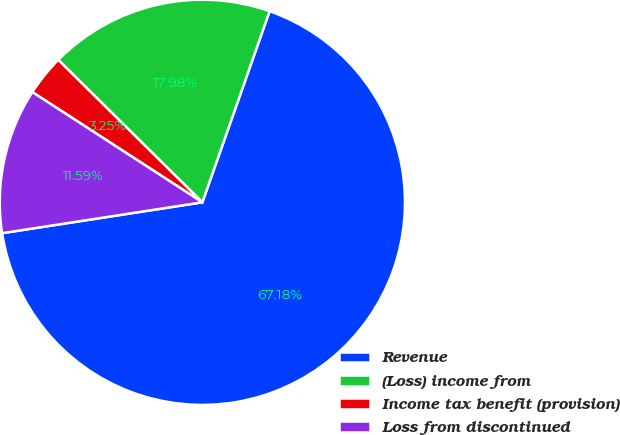<chart> <loc_0><loc_0><loc_500><loc_500><pie_chart><fcel>Revenue<fcel>(Loss) income from<fcel>Income tax benefit (provision)<fcel>Loss from discontinued<nl><fcel>67.18%<fcel>17.98%<fcel>3.25%<fcel>11.59%<nl></chart> 